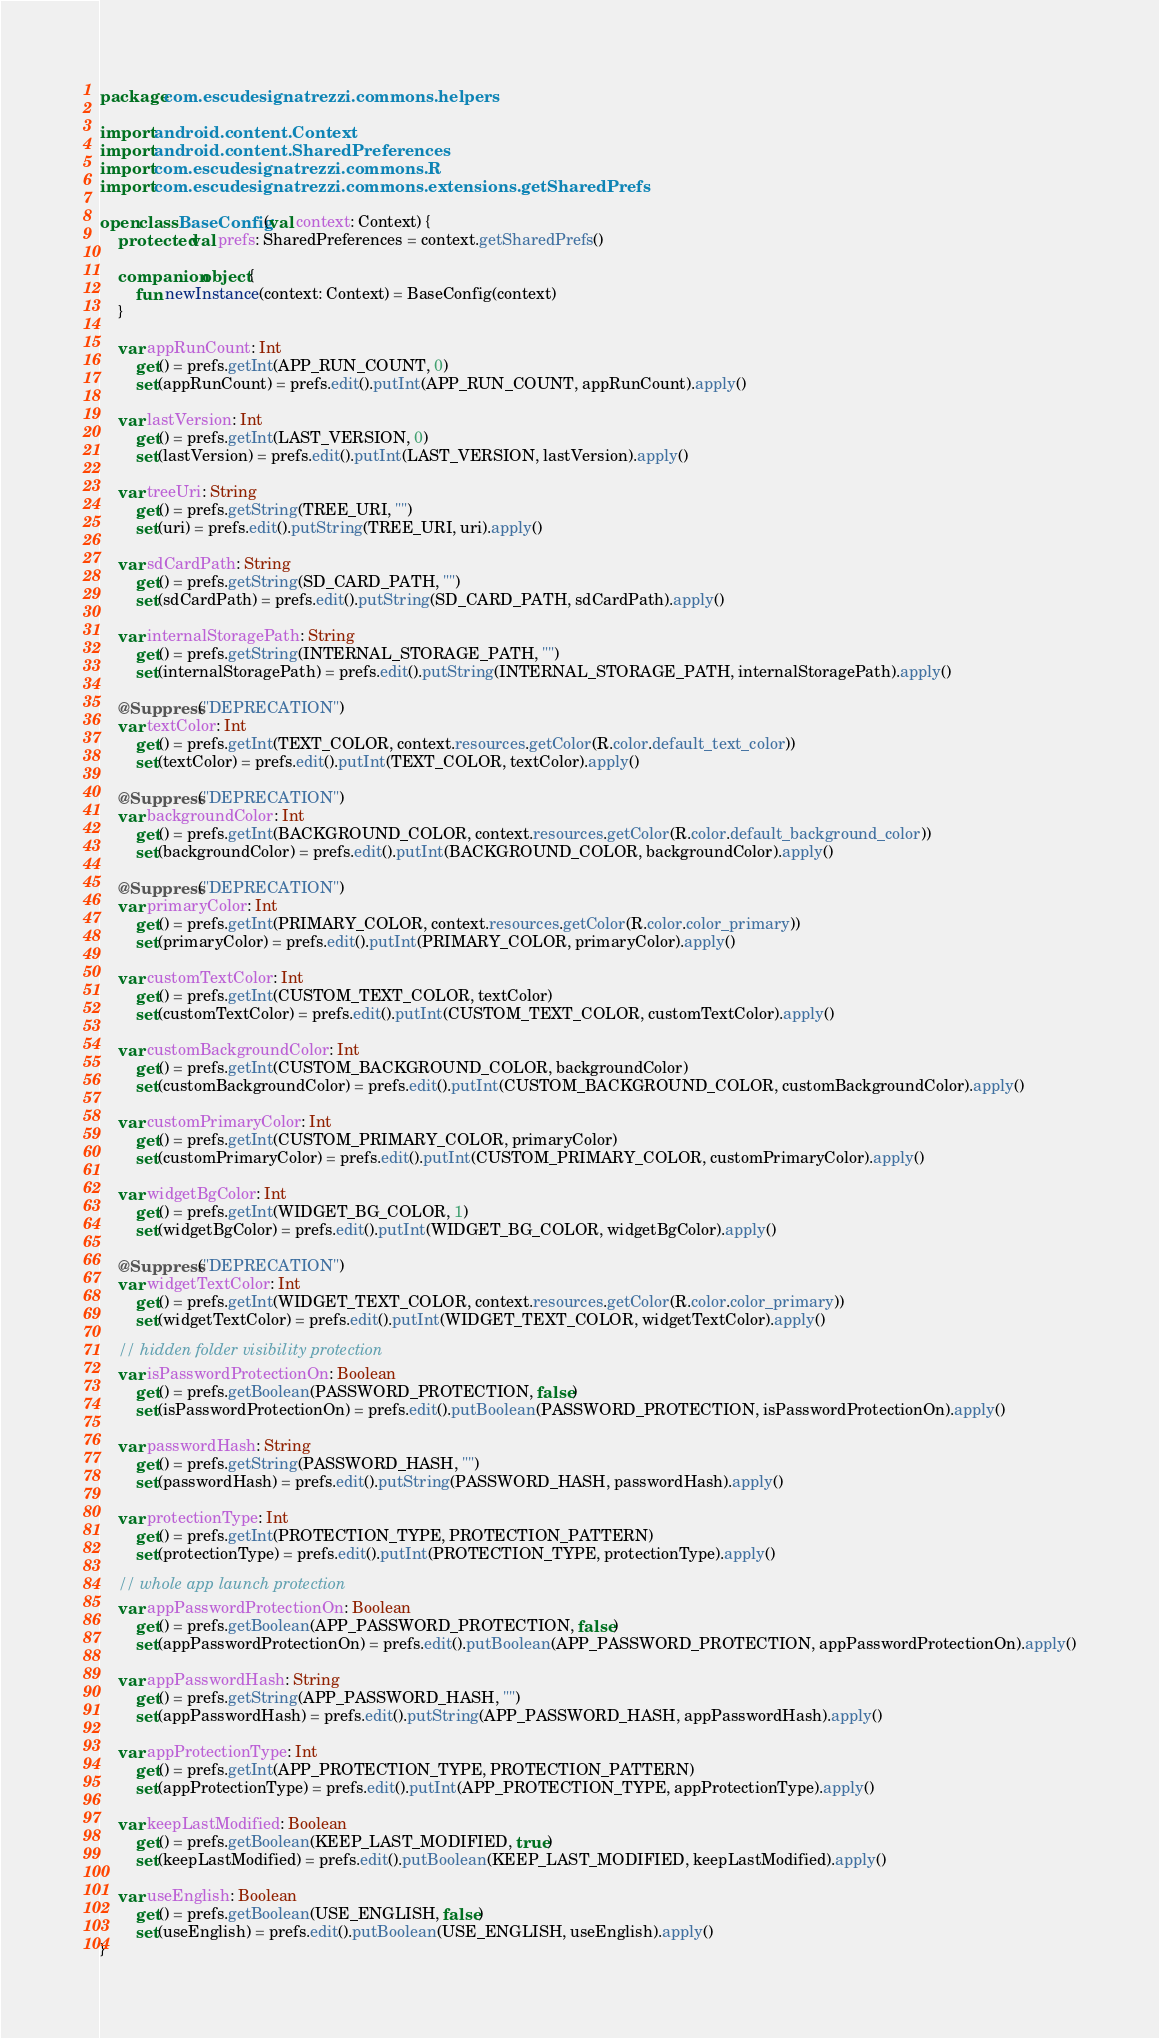Convert code to text. <code><loc_0><loc_0><loc_500><loc_500><_Kotlin_>package com.escudesignatrezzi.commons.helpers

import android.content.Context
import android.content.SharedPreferences
import com.escudesignatrezzi.commons.R
import com.escudesignatrezzi.commons.extensions.getSharedPrefs

open class BaseConfig(val context: Context) {
    protected val prefs: SharedPreferences = context.getSharedPrefs()

    companion object {
        fun newInstance(context: Context) = BaseConfig(context)
    }

    var appRunCount: Int
        get() = prefs.getInt(APP_RUN_COUNT, 0)
        set(appRunCount) = prefs.edit().putInt(APP_RUN_COUNT, appRunCount).apply()

    var lastVersion: Int
        get() = prefs.getInt(LAST_VERSION, 0)
        set(lastVersion) = prefs.edit().putInt(LAST_VERSION, lastVersion).apply()

    var treeUri: String
        get() = prefs.getString(TREE_URI, "")
        set(uri) = prefs.edit().putString(TREE_URI, uri).apply()

    var sdCardPath: String
        get() = prefs.getString(SD_CARD_PATH, "")
        set(sdCardPath) = prefs.edit().putString(SD_CARD_PATH, sdCardPath).apply()

    var internalStoragePath: String
        get() = prefs.getString(INTERNAL_STORAGE_PATH, "")
        set(internalStoragePath) = prefs.edit().putString(INTERNAL_STORAGE_PATH, internalStoragePath).apply()

    @Suppress("DEPRECATION")
    var textColor: Int
        get() = prefs.getInt(TEXT_COLOR, context.resources.getColor(R.color.default_text_color))
        set(textColor) = prefs.edit().putInt(TEXT_COLOR, textColor).apply()

    @Suppress("DEPRECATION")
    var backgroundColor: Int
        get() = prefs.getInt(BACKGROUND_COLOR, context.resources.getColor(R.color.default_background_color))
        set(backgroundColor) = prefs.edit().putInt(BACKGROUND_COLOR, backgroundColor).apply()

    @Suppress("DEPRECATION")
    var primaryColor: Int
        get() = prefs.getInt(PRIMARY_COLOR, context.resources.getColor(R.color.color_primary))
        set(primaryColor) = prefs.edit().putInt(PRIMARY_COLOR, primaryColor).apply()

    var customTextColor: Int
        get() = prefs.getInt(CUSTOM_TEXT_COLOR, textColor)
        set(customTextColor) = prefs.edit().putInt(CUSTOM_TEXT_COLOR, customTextColor).apply()

    var customBackgroundColor: Int
        get() = prefs.getInt(CUSTOM_BACKGROUND_COLOR, backgroundColor)
        set(customBackgroundColor) = prefs.edit().putInt(CUSTOM_BACKGROUND_COLOR, customBackgroundColor).apply()

    var customPrimaryColor: Int
        get() = prefs.getInt(CUSTOM_PRIMARY_COLOR, primaryColor)
        set(customPrimaryColor) = prefs.edit().putInt(CUSTOM_PRIMARY_COLOR, customPrimaryColor).apply()

    var widgetBgColor: Int
        get() = prefs.getInt(WIDGET_BG_COLOR, 1)
        set(widgetBgColor) = prefs.edit().putInt(WIDGET_BG_COLOR, widgetBgColor).apply()

    @Suppress("DEPRECATION")
    var widgetTextColor: Int
        get() = prefs.getInt(WIDGET_TEXT_COLOR, context.resources.getColor(R.color.color_primary))
        set(widgetTextColor) = prefs.edit().putInt(WIDGET_TEXT_COLOR, widgetTextColor).apply()

    // hidden folder visibility protection
    var isPasswordProtectionOn: Boolean
        get() = prefs.getBoolean(PASSWORD_PROTECTION, false)
        set(isPasswordProtectionOn) = prefs.edit().putBoolean(PASSWORD_PROTECTION, isPasswordProtectionOn).apply()

    var passwordHash: String
        get() = prefs.getString(PASSWORD_HASH, "")
        set(passwordHash) = prefs.edit().putString(PASSWORD_HASH, passwordHash).apply()

    var protectionType: Int
        get() = prefs.getInt(PROTECTION_TYPE, PROTECTION_PATTERN)
        set(protectionType) = prefs.edit().putInt(PROTECTION_TYPE, protectionType).apply()

    // whole app launch protection
    var appPasswordProtectionOn: Boolean
        get() = prefs.getBoolean(APP_PASSWORD_PROTECTION, false)
        set(appPasswordProtectionOn) = prefs.edit().putBoolean(APP_PASSWORD_PROTECTION, appPasswordProtectionOn).apply()

    var appPasswordHash: String
        get() = prefs.getString(APP_PASSWORD_HASH, "")
        set(appPasswordHash) = prefs.edit().putString(APP_PASSWORD_HASH, appPasswordHash).apply()

    var appProtectionType: Int
        get() = prefs.getInt(APP_PROTECTION_TYPE, PROTECTION_PATTERN)
        set(appProtectionType) = prefs.edit().putInt(APP_PROTECTION_TYPE, appProtectionType).apply()

    var keepLastModified: Boolean
        get() = prefs.getBoolean(KEEP_LAST_MODIFIED, true)
        set(keepLastModified) = prefs.edit().putBoolean(KEEP_LAST_MODIFIED, keepLastModified).apply()

    var useEnglish: Boolean
        get() = prefs.getBoolean(USE_ENGLISH, false)
        set(useEnglish) = prefs.edit().putBoolean(USE_ENGLISH, useEnglish).apply()
}
</code> 